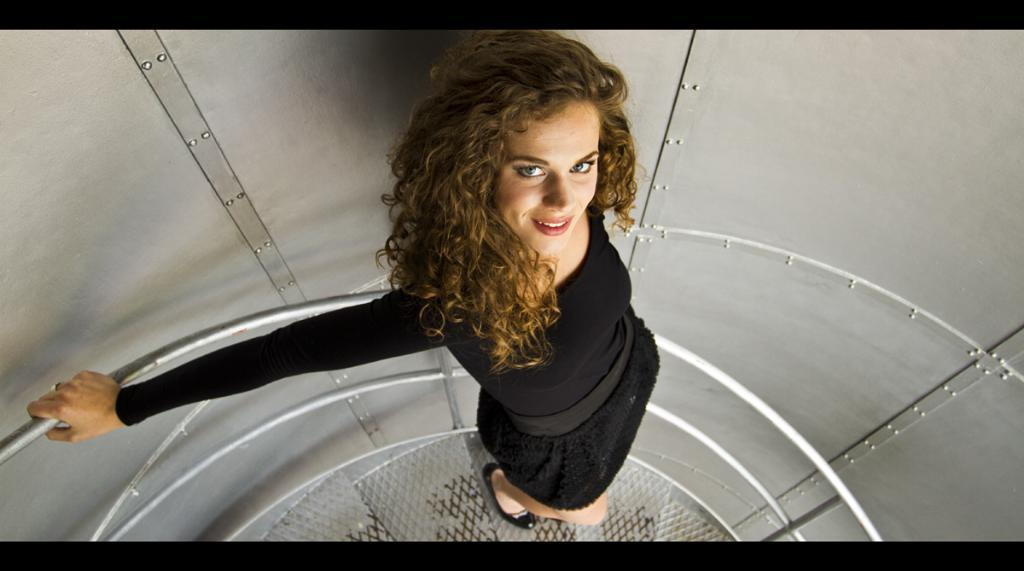Who is present in the image? There is a woman in the image. What is the woman doing in the image? The woman is standing on a staircase. What can be seen in the background of the image? There is a wall in the background of the image. What type of food is the woman eating in the image? There is no food present in the image, and the woman is not shown eating anything. 